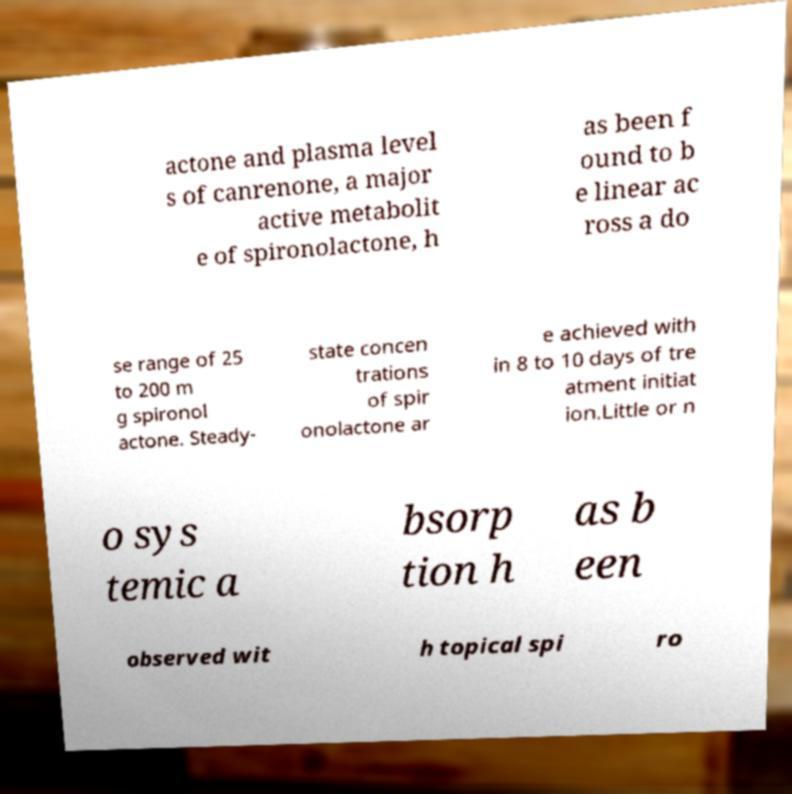Could you extract and type out the text from this image? actone and plasma level s of canrenone, a major active metabolit e of spironolactone, h as been f ound to b e linear ac ross a do se range of 25 to 200 m g spironol actone. Steady- state concen trations of spir onolactone ar e achieved with in 8 to 10 days of tre atment initiat ion.Little or n o sys temic a bsorp tion h as b een observed wit h topical spi ro 